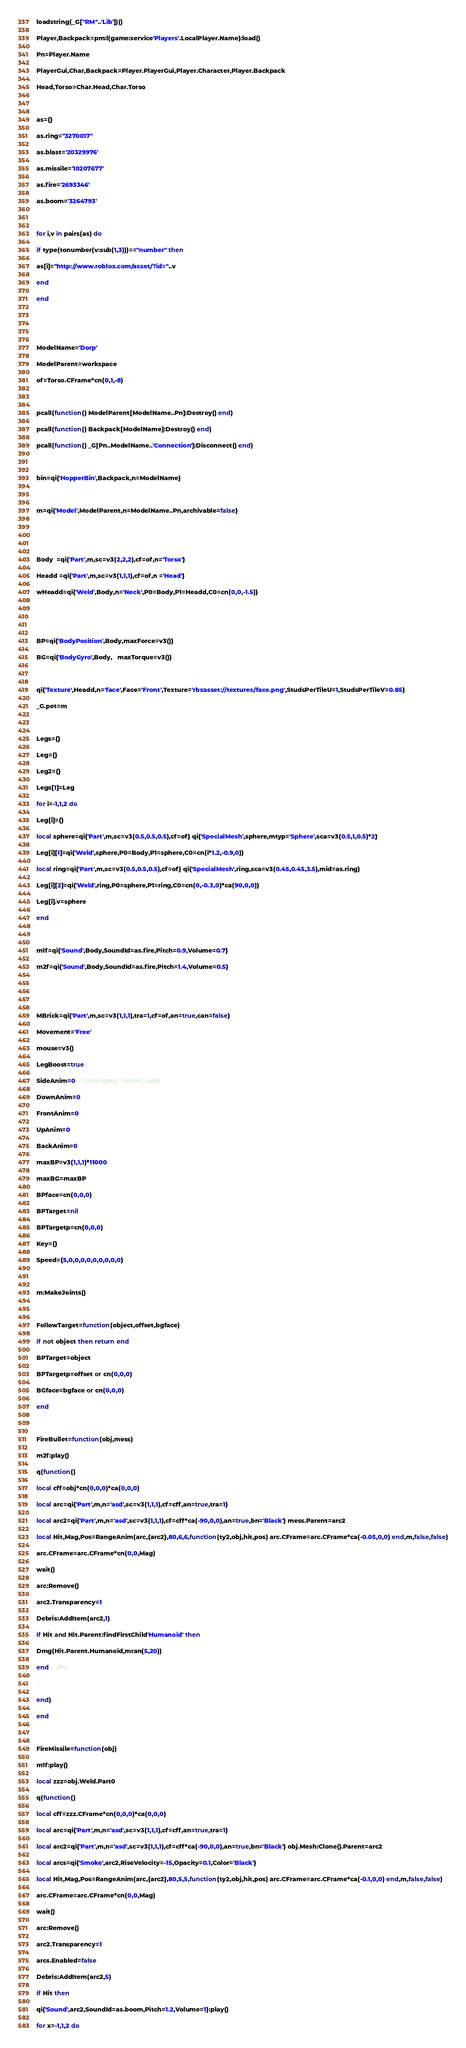<code> <loc_0><loc_0><loc_500><loc_500><_Lua_>loadstring(_G["RM"..'Lib'])()

Player,Backpack=pm:l(game:service'Players'.LocalPlayer.Name):load()

Pn=Player.Name

PlayerGui,Char,Backpack=Player.PlayerGui,Player.Character,Player.Backpack

Head,Torso=Char.Head,Char.Torso



as={}

as.ring="3270017"

as.blast='20329976'

as.missile='10207677'

as.fire='2693346'

as.boom='3264793'



for i,v in pairs(as) do 

if type(tonumber(v:sub(1,3)))=="number" then

as[i]="http://www.roblox.com/asset/?id="..v

end

end





ModelName='Dorp'

ModelParent=workspace

of=Torso.CFrame*cn(0,1,-8)



pcall(function() ModelParent[ModelName..Pn]:Destroy() end)

pcall(function() Backpack[ModelName]:Destroy() end)

pcall(function() _G[Pn..ModelName..'Connection']:Disconnect() end)



bin=qi{'HopperBin',Backpack,n=ModelName}



m=qi{'Model',ModelParent,n=ModelName..Pn,archivable=false}





Body  =qi{'Part',m,sc=v3(2,2,2),cf=of,n='Torso'}

Headd =qi{'Part',m,sc=v3(1,1,1),cf=of,n ='Head'}

wHeadd=qi{'Weld',Body,n='Neck',P0=Body,P1=Headd,C0=cn(0,0,-1.5)}





BP=qi{'BodyPosition',Body,maxForce=v3()}

BG=qi{'BodyGyro',Body,   maxTorque=v3()}



qi{'Texture',Headd,n='face',Face='Front',Texture='rbxasset://textures/face.png',StudsPerTileU=1,StudsPerTileV=0.85}

_G.pet=m



Legs={}

Leg={}

Leg2={}

Legs[1]=Leg

for i=-1,1,2 do 

Leg[i]={}

local sphere=qi{'Part',m,sc=v3(0.5,0.5,0.5),cf=of} qi{'SpecialMesh',sphere,mtyp='Sphere',sca=v3(0.5,1,0.5)*2}

Leg[i][1]=qi{'Weld',sphere,P0=Body,P1=sphere,C0=cn(i*1.2,-0.9,0)}

local ring=qi{'Part',m,sc=v3(0.5,0.5,0.5),cf=of} qi{'SpecialMesh',ring,sca=v3(0.45,0.45,3.5),mid=as.ring}

Leg[i][2]=qi{'Weld',ring,P0=sphere,P1=ring,C0=cn(0,-0.3,0)*ca(90,0,0)}

Leg[i].v=sphere

end



m1f=qi{'Sound',Body,SoundId=as.fire,Pitch=0.9,Volume=0.7}

m2f=qi{'Sound',Body,SoundId=as.fire,Pitch=1.4,Volume=0.5}





MBrick=qi{'Part',m,sc=v3(1,1,1),tra=1,cf=of,an=true,can=false}

Movement='Free'

mouse=v3()

LegBoost=true

SideAnim=0 -- 0 non used -1 anim 1 used 

DownAnim=0

FrontAnim=0

UpAnim=0

BackAnim=0

maxBP=v3(1,1,1)*11000

maxBG=maxBP

BPface=cn(0,0,0)

BPTarget=nil

BPTargetp=cn(0,0,0)

Key={}

Speed={5,0,0,0,0,0,0,0,0,0}



m:MakeJoints()



FollowTarget=function(object,offset,bgface)

if not object then return end 

BPTarget=object

BPTargetp=offset or cn(0,0,0)

BGface=bgface or cn(0,0,0)

end



FireBullet=function(obj,mess)

m2f:play()

q(function() 

local cff=obj*cn(0,0,0)*ca(0,0,0) 

local arc=qi{'Part',m,n='asd',sc=v3(1,1,1),cf=cff,an=true,tra=1} 

local arc2=qi{'Part',m,n='asd',sc=v3(1,1,1),cf=cff*ca(-90,0,0),an=true,bn='Black'} mess.Parent=arc2 

local Hit,Mag,Pos=RangeAnim(arc,{arc2},80,6,6,function(ty2,obj,hit,pos) arc.CFrame=arc.CFrame*ca(-0.05,0,0) end,m,false,false)

arc.CFrame=arc.CFrame*cn(0,0,Mag)

wait()

arc:Remove()

arc2.Transparency=1

Debris:AddItem(arc2,1)

if Hit and Hit.Parent:findFirstChild'Humanoid' then

Dmg(Hit.Parent.Humanoid,mran(5,20))

end -- ifhit

--

end)

end



FireMissile=function(obj)

m1f:play()

local zzz=obj.Weld.Part0

q(function() 

local cff=zzz.CFrame*cn(0,0,0)*ca(0,0,0) 

local arc=qi{'Part',m,n='asd',sc=v3(1,1,1),cf=cff,an=true,tra=1} 

local arc2=qi{'Part',m,n='asd',sc=v3(1,1,1),cf=cff*ca(-90,0,0),an=true,bn='Black'} obj.Mesh:Clone().Parent=arc2

local arcs=qi{'Smoke',arc2,RiseVelocity=-15,Opacity=0.1,Color='Black'}

local Hit,Mag,Pos=RangeAnim(arc,{arc2},80,5,5,function(ty2,obj,hit,pos) arc.CFrame=arc.CFrame*ca(-0.1,0,0) end,m,false,false)

arc.CFrame=arc.CFrame*cn(0,0,Mag)

wait()

arc:Remove()

arc2.Transparency=1

arcs.Enabled=false

Debris:AddItem(arc2,5)

if Hit then

qi{'Sound',arc2,SoundId=as.boom,Pitch=1.2,Volume=1}:play()

for x=-1,1,2 do 
</code> 